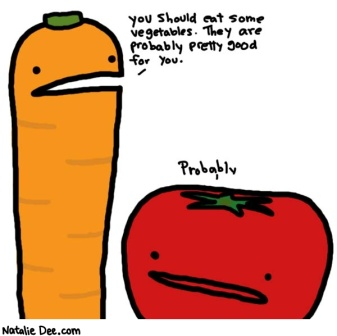What kind of conversation do you think the carrot and the tomato might have if they could talk more? Carrot: 'I really think you should start eating more vegetables. They're filled with vitamins and nutrients that are unmatched by any other food group.'
Tomato: 'Yeah, I hear you. But what if they don't taste good?'
Carrot: 'Well, you never know until you try! We've got a lot of flavors to offer.'
Tomato: 'Hmm, alright, maybe I'll give it a try. But only if you promise to add some dressing.'
Carrot: 'Deal! Let's make eating healthy a delicious adventure together!' What if the vegetables could team up to promote a healthy lifestyle in a school setting? Carrot: 'Greetings, students! I'm Carrot, and I'm here to show you how eating your veggies can make you strong and smart!'
Tomato: 'And I'm Tomato! We'll make sure you enjoy every crunchy bite and juicy flavor. Let's dive into the world of vegetables!' 
Carrot: 'Did you know, kids, that vegetables like me are rich in fiber, which keeps your digestive system happy?' 
Tomato: 'And I'm packed with antioxidants, which help keep your body healthy and fight off sickness. We make a great team!' 
Carrot: 'Let's not forget our friend Broccoli. He's a powerhouse of vitamins and minerals. We're all essential to keeping you healthy.' 
Tomato: 'So remember, eat your vegetables every day, and you'll grow up strong and healthy! Who's ready to join us on this healthy adventure?' 
Students: 'We are!' 